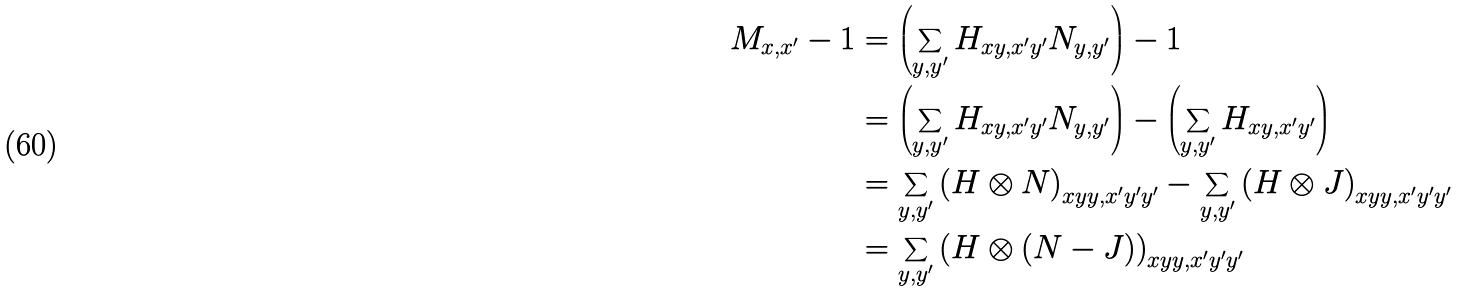Convert formula to latex. <formula><loc_0><loc_0><loc_500><loc_500>M _ { x , x ^ { \prime } } - 1 & = \left ( \sum _ { y , y ^ { \prime } } H _ { x y , x ^ { \prime } y ^ { \prime } } N _ { y , y ^ { \prime } } \right ) - 1 \\ & = \left ( \sum _ { y , y ^ { \prime } } H _ { x y , x ^ { \prime } y ^ { \prime } } N _ { y , y ^ { \prime } } \right ) - \left ( \sum _ { y , y ^ { \prime } } H _ { x y , x ^ { \prime } y ^ { \prime } } \right ) \\ & = \sum _ { y , y ^ { \prime } } \left ( H \otimes N \right ) _ { x y y , x ^ { \prime } y ^ { \prime } y ^ { \prime } } - \sum _ { y , y ^ { \prime } } \left ( H \otimes J \right ) _ { x y y , x ^ { \prime } y ^ { \prime } y ^ { \prime } } \\ & = \sum _ { y , y ^ { \prime } } \left ( H \otimes \left ( N - J \right ) \right ) _ { x y y , x ^ { \prime } y ^ { \prime } y ^ { \prime } }</formula> 